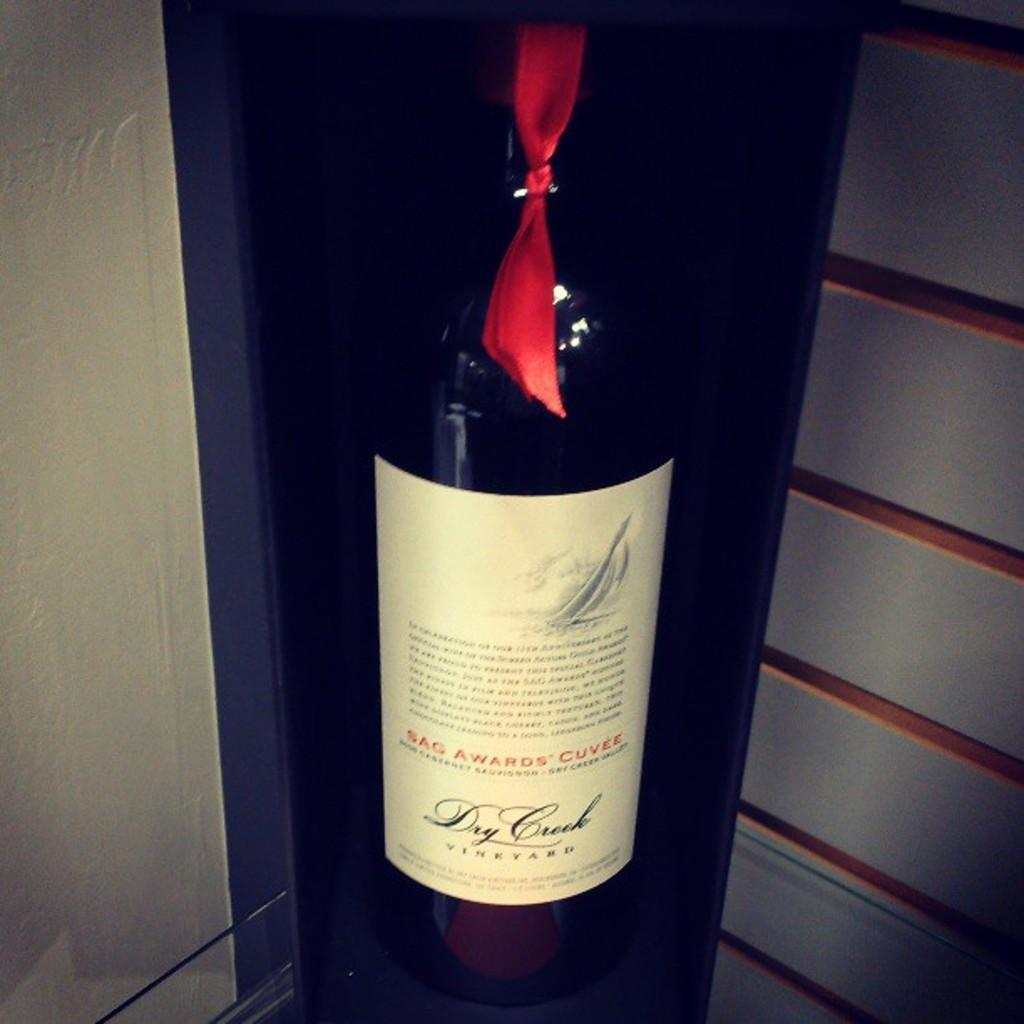<image>
Render a clear and concise summary of the photo. A bottle of Dry Crock Vineyard wine is on a display with a red ribbon tied around the neck. 